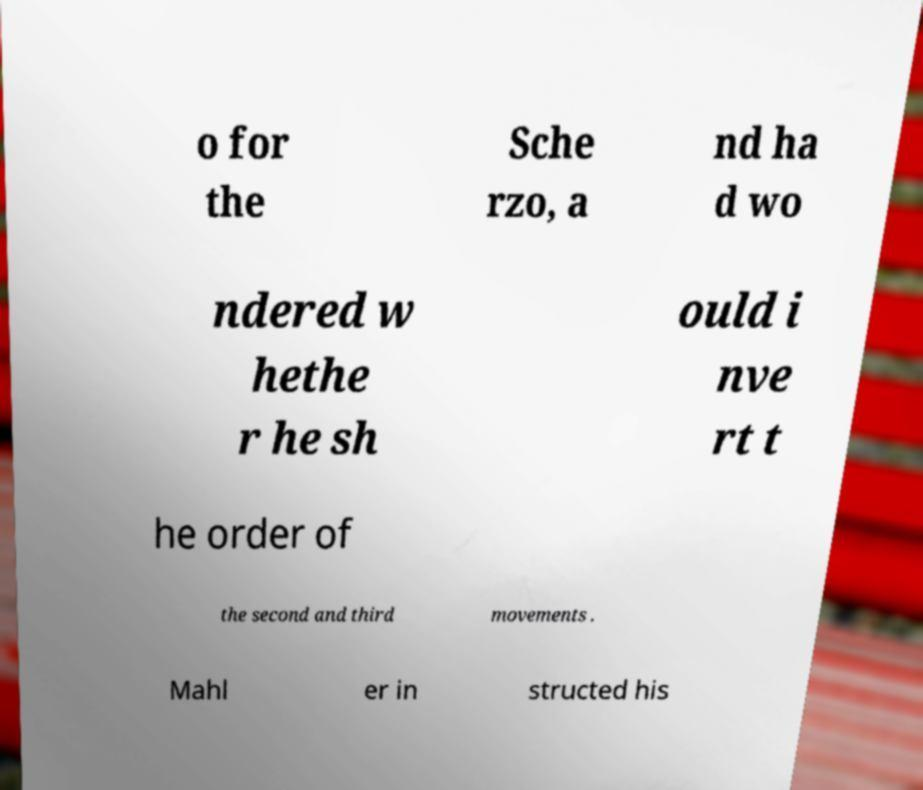There's text embedded in this image that I need extracted. Can you transcribe it verbatim? o for the Sche rzo, a nd ha d wo ndered w hethe r he sh ould i nve rt t he order of the second and third movements . Mahl er in structed his 